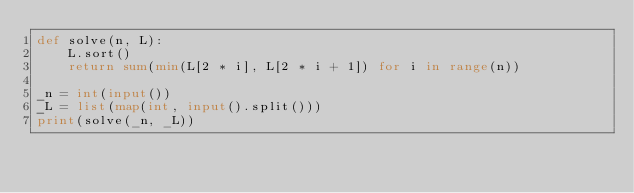Convert code to text. <code><loc_0><loc_0><loc_500><loc_500><_Python_>def solve(n, L):
    L.sort()
    return sum(min(L[2 * i], L[2 * i + 1]) for i in range(n))

_n = int(input())
_L = list(map(int, input().split()))
print(solve(_n, _L))
</code> 